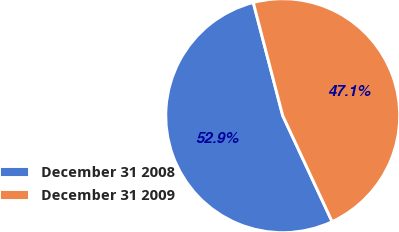Convert chart to OTSL. <chart><loc_0><loc_0><loc_500><loc_500><pie_chart><fcel>December 31 2008<fcel>December 31 2009<nl><fcel>52.89%<fcel>47.11%<nl></chart> 